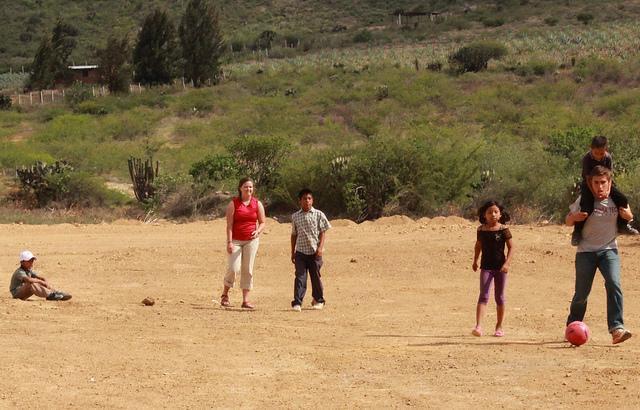How many people are over the age of 18?
Give a very brief answer. 2. How many people are in the picture?
Give a very brief answer. 4. 